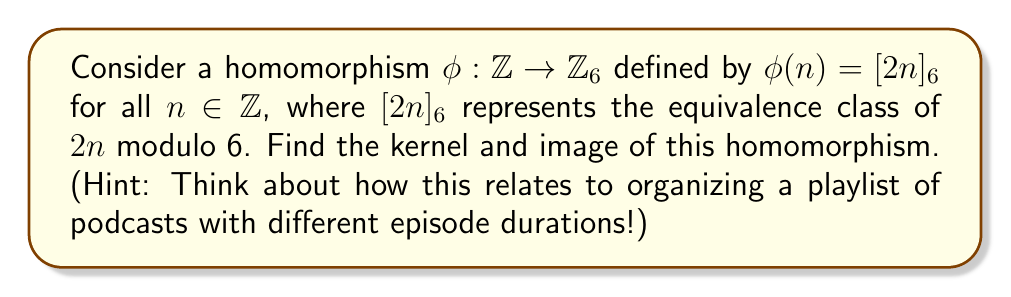Can you solve this math problem? Let's approach this step-by-step:

1) First, let's recall the definitions:
   - The kernel of a homomorphism $\phi$ is the set of all elements in the domain that map to the identity element in the codomain.
   - The image of a homomorphism $\phi$ is the set of all elements in the codomain that are mapped to by at least one element in the domain.

2) For $\mathbb{Z}_6$, the identity element is $[0]_6$.

3) To find the kernel, we need to solve the equation:
   $\phi(n) = [2n]_6 = [0]_6$
   
   This is equivalent to solving:
   $2n \equiv 0 \pmod{6}$
   
   The solutions to this are all multiples of 3:
   $n = 3k$, where $k \in \mathbb{Z}$

4) Therefore, the kernel is:
   $\text{ker}(\phi) = \{3k : k \in \mathbb{Z}\} = 3\mathbb{Z}$

5) To find the image, let's consider what elements we can get in $\mathbb{Z}_6$:
   $\phi(0) = [0]_6$
   $\phi(1) = [2]_6$
   $\phi(2) = [4]_6$
   $\phi(3) = [0]_6$
   $\phi(4) = [2]_6$
   $\phi(5) = [4]_6$

6) We see that the image consists of $[0]_6$, $[2]_6$, and $[4]_6$.

7) Therefore, the image is:
   $\text{Im}(\phi) = \{[0]_6, [2]_6, [4]_6\}$

This relates to organizing a playlist because the kernel represents the "rhythm" of the playlist (every 3 episodes), while the image represents the "variety" of episode durations available (0, 2, or 4 minutes mod 6).
Answer: Kernel: $\text{ker}(\phi) = 3\mathbb{Z} = \{3k : k \in \mathbb{Z}\}$
Image: $\text{Im}(\phi) = \{[0]_6, [2]_6, [4]_6\}$ 